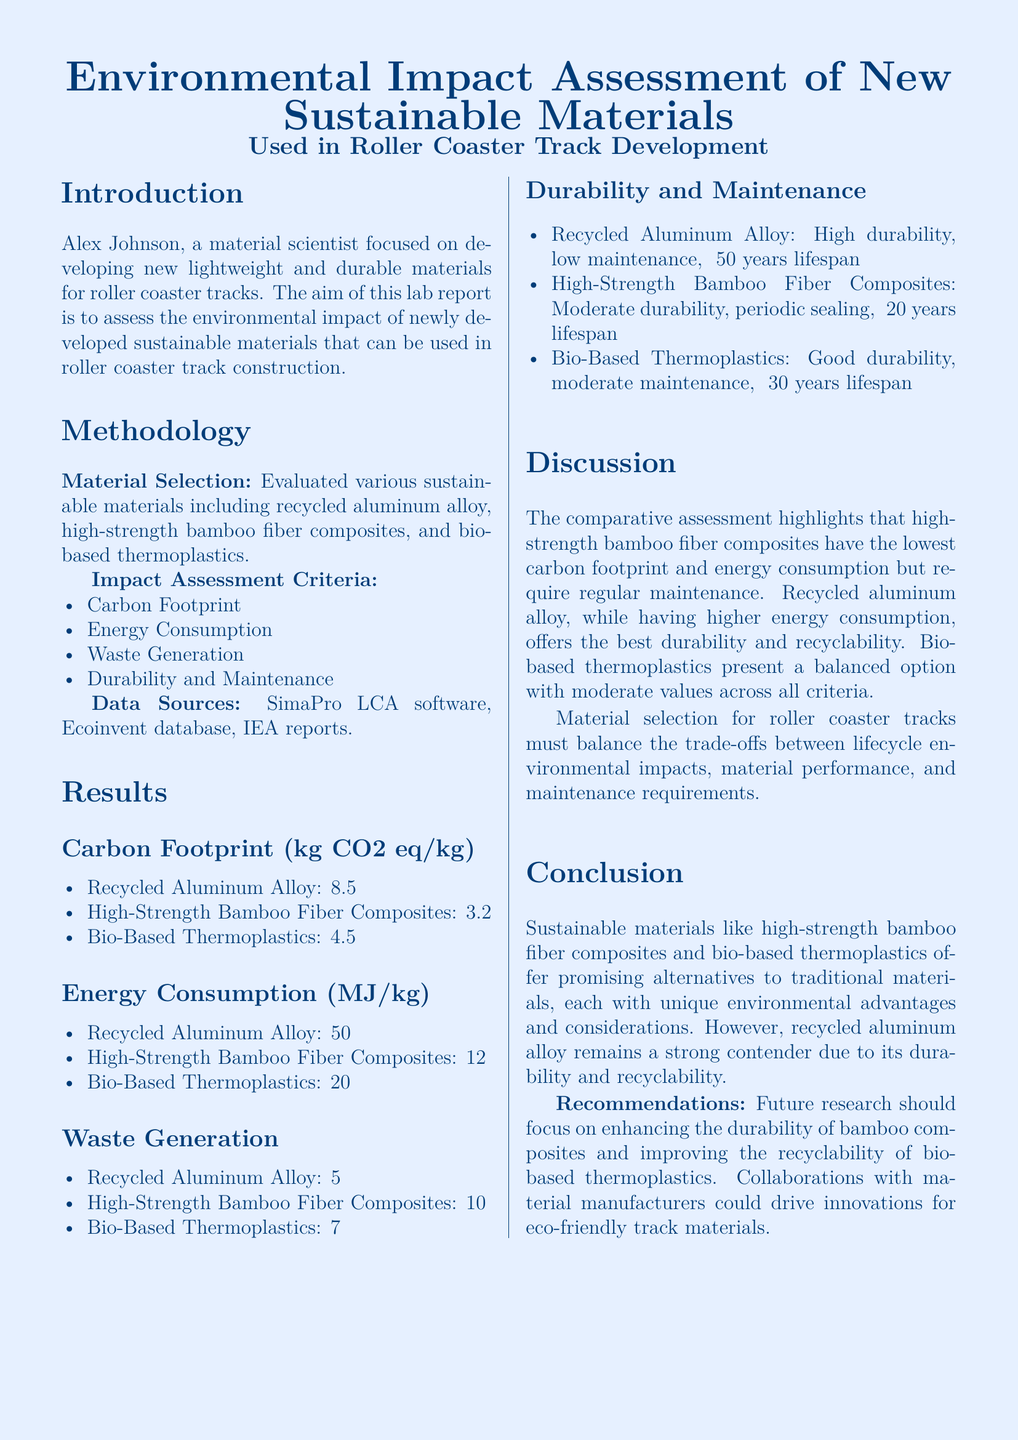What is the focus of Alex Johnson's research? The document states that Alex Johnson is a material scientist focused on developing new lightweight and durable materials for roller coaster tracks.
Answer: lightweight and durable materials for roller coaster tracks What is the carbon footprint of high-strength bamboo fiber composites? The carbon footprint for high-strength bamboo fiber composites is provided in the results section of the document.
Answer: 3.2 How much energy is consumed by recycled aluminum alloy per kilogram? The energy consumption for recycled aluminum alloy is noted in the results section.
Answer: 50 What is the production waste percentage of bio-based thermoplastics? The document lists the production waste for bio-based thermoplastics, indicating the percentage for waste generation.
Answer: 7% Which material has the highest lifespan according to the durability section? The durability section lists the lifespan of each material. Recycled aluminum alloy has the highest lifespan.
Answer: ~50 years lifespan What is the recommendation for future research? The document contains a specific recommendation regarding future research focus in the conclusion section.
Answer: Enhancing the durability of bamboo composites Which material is described as compostable? The waste generation section identifies which material is compostable.
Answer: High-Strength Bamboo Fiber Composites What does the discussion suggest about high-strength bamboo fiber composites? The discussion provides insights into the environmental impacts and characteristics of bamboo fiber composites, emphasizing a particular aspect.
Answer: lowest carbon footprint and energy consumption 